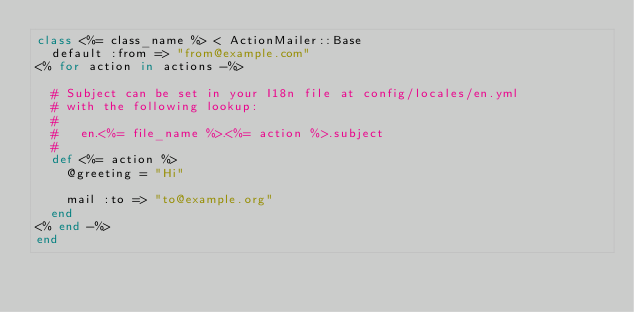Convert code to text. <code><loc_0><loc_0><loc_500><loc_500><_Ruby_>class <%= class_name %> < ActionMailer::Base
  default :from => "from@example.com"
<% for action in actions -%>

  # Subject can be set in your I18n file at config/locales/en.yml
  # with the following lookup:
  #
  #   en.<%= file_name %>.<%= action %>.subject
  #
  def <%= action %>
    @greeting = "Hi"

    mail :to => "to@example.org"
  end
<% end -%>
end
</code> 